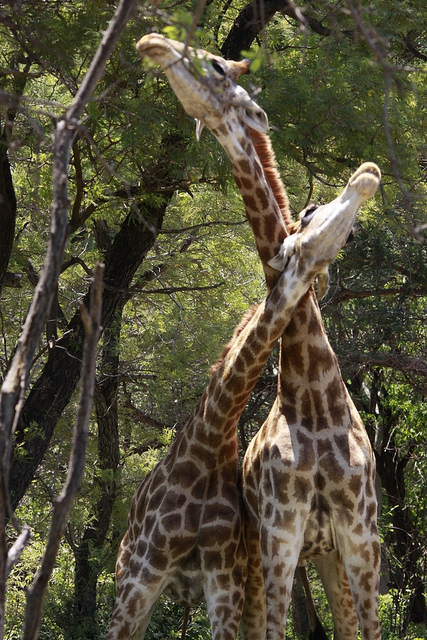Can you describe the environment in which these giraffes are found? Certainly! The giraffes are in a wooded savanna, surrounded by dense trees offering ample shade and food sources. The sunlight filters through the foliage, dappling the ground and highlighting the giraffes' spotted coats, which blend beautifully with the surrounding vegetation, illustrating their natural camouflage. 